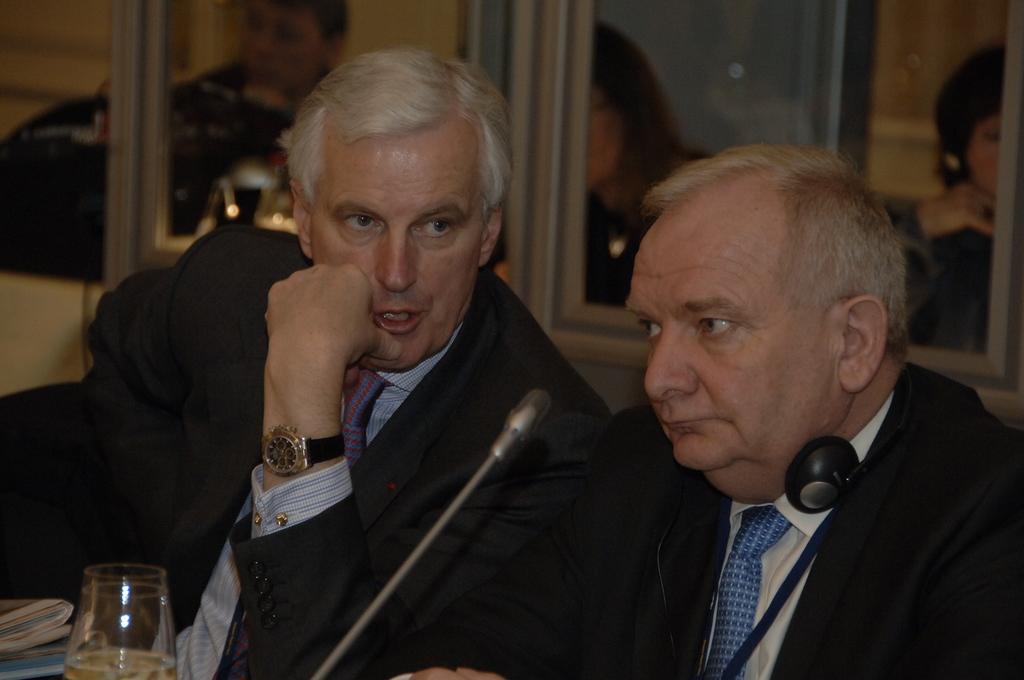Please provide a concise description of this image. In this picture we can see few people, they are seated on the chairs, in the middle of the image we can find a glass and a microphone, in the right side of the given image we can see a man, he wore a headset. 